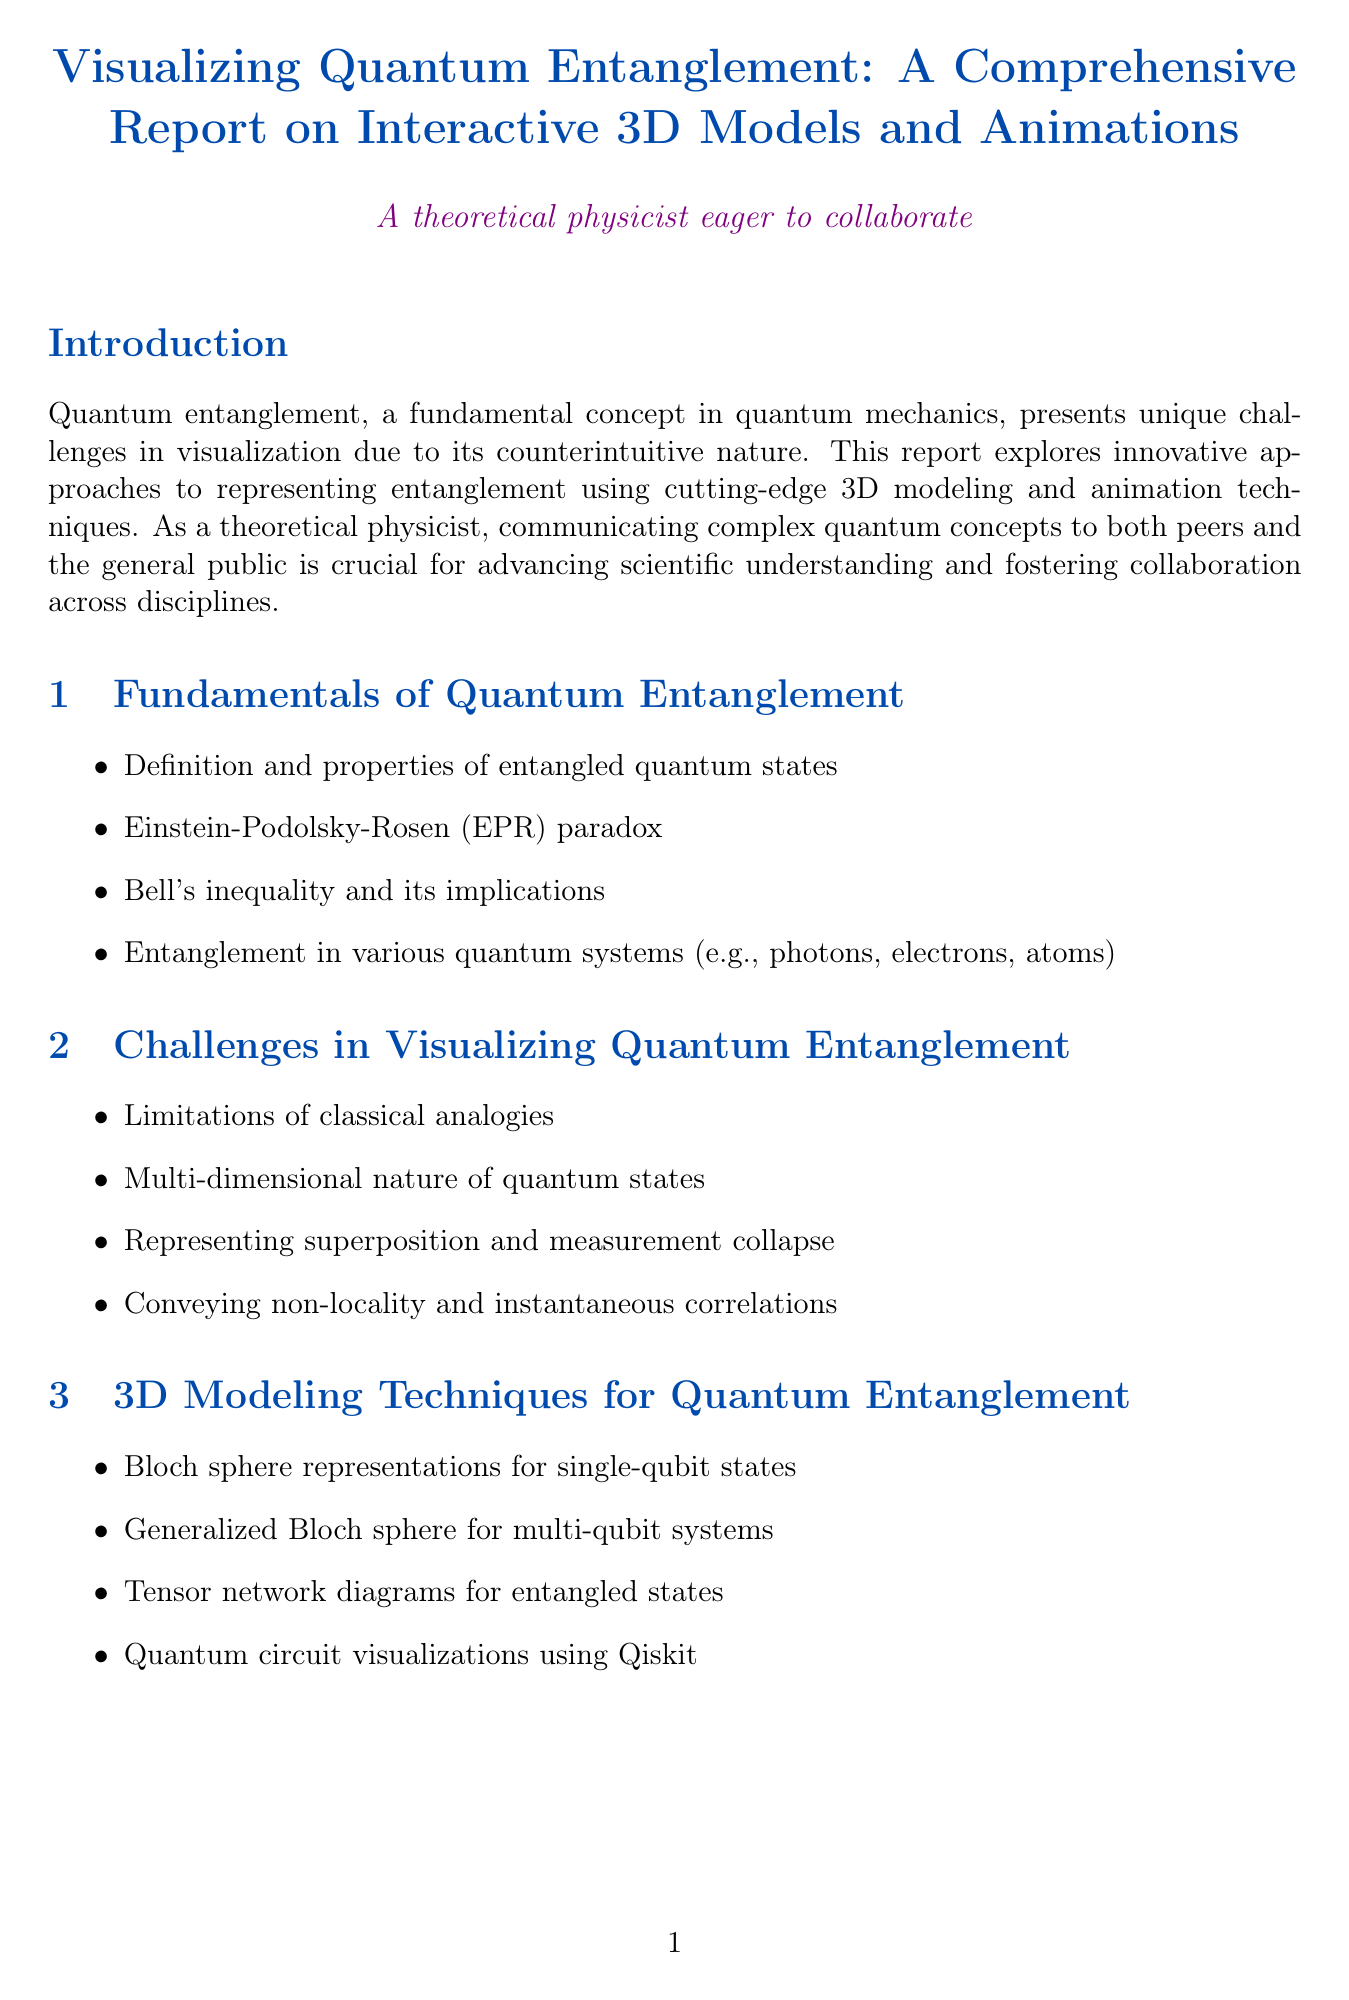What is the title of the report? The title is presented at the beginning of the document in a formatted way.
Answer: Visualizing Quantum Entanglement: A Comprehensive Report on Interactive 3D Models and Animations What is one challenge in visualizing quantum entanglement? The document lists multiple challenges in visualization within the relevant section.
Answer: Limitations of classical analogies Which software is used for generating Wigner functions? The document specifies tools used in creating visualizations, including one for Wigner functions.
Answer: QuTiP What visualization technique is used for single-qubit states? The report describes specific 3D modeling techniques under the relevant section.
Answer: Bloch sphere representations Name one case study mentioned in the document. The case studies section provides specific examples of successful visualizations in research.
Answer: IBM's quantum computer architecture visualizations What emerging technology involves holograms? Future directions are discussed, focusing on technologies that could enhance quantum visualizations.
Answer: Holographic displays How many references are listed in the document? At the end of the document, the number of references can be counted.
Answer: Five What is a platform mentioned for sharing quantum visualizations? The section on collaborative platforms provides examples of where visualizations can be shared.
Answer: GitHub repositories 